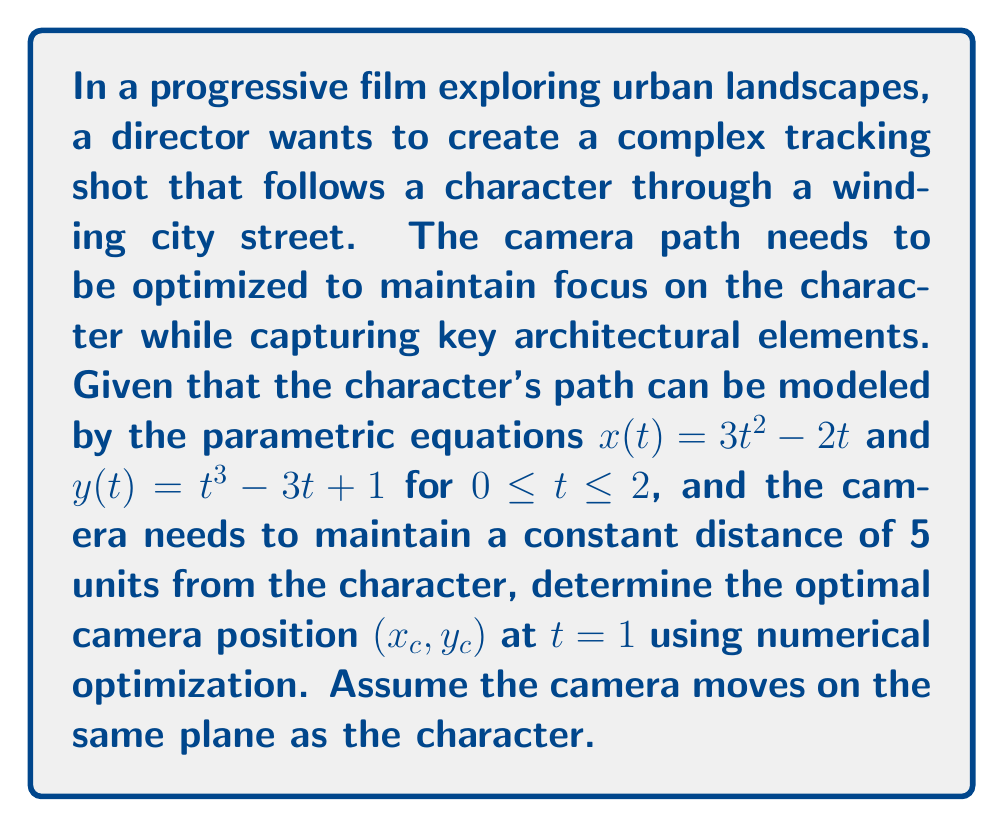Solve this math problem. To solve this problem, we'll follow these steps:

1) First, we need to express the distance between the camera and the character as a function to minimize. Let's call this function $f(x_c, y_c)$.

2) The distance between two points $(x_1, y_1)$ and $(x_2, y_2)$ is given by $\sqrt{(x_2-x_1)^2 + (y_2-y_1)^2}$. In our case:

   $f(x_c, y_c) = \left[(x_c - x(t))^2 + (y_c - y(t))^2 - 5^2\right]^2$

   We square the difference from 25 (5^2) to ensure we're always minimizing a positive value.

3) At $t = 1$, we can calculate the character's position:
   $x(1) = 3(1)^2 - 2(1) = 1$
   $y(1) = (1)^3 - 3(1) + 1 = -1$

4) Now our function becomes:
   $f(x_c, y_c) = \left[(x_c - 1)^2 + (y_c + 1)^2 - 25\right]^2$

5) To minimize this function, we need to find where its partial derivatives equal zero:

   $\frac{\partial f}{\partial x_c} = 4(x_c - 1)\left[(x_c - 1)^2 + (y_c + 1)^2 - 25\right] = 0$
   $\frac{\partial f}{\partial y_c} = 4(y_c + 1)\left[(x_c - 1)^2 + (y_c + 1)^2 - 25\right] = 0$

6) These equations are satisfied when $(x_c - 1)^2 + (y_c + 1)^2 = 25$, which is the equation of a circle with radius 5 centered at (1, -1).

7) There are infinitely many solutions on this circle. One solution can be found by choosing:
   $x_c = 1 + 5\cos\theta$
   $y_c = -1 + 5\sin\theta$

   where $\theta$ can be any angle. For simplicity, we can choose $\theta = 0$.

Therefore, one optimal camera position at $t = 1$ is (6, -1).
Answer: An optimal camera position at $t = 1$ is $(x_c, y_c) = (6, -1)$. 